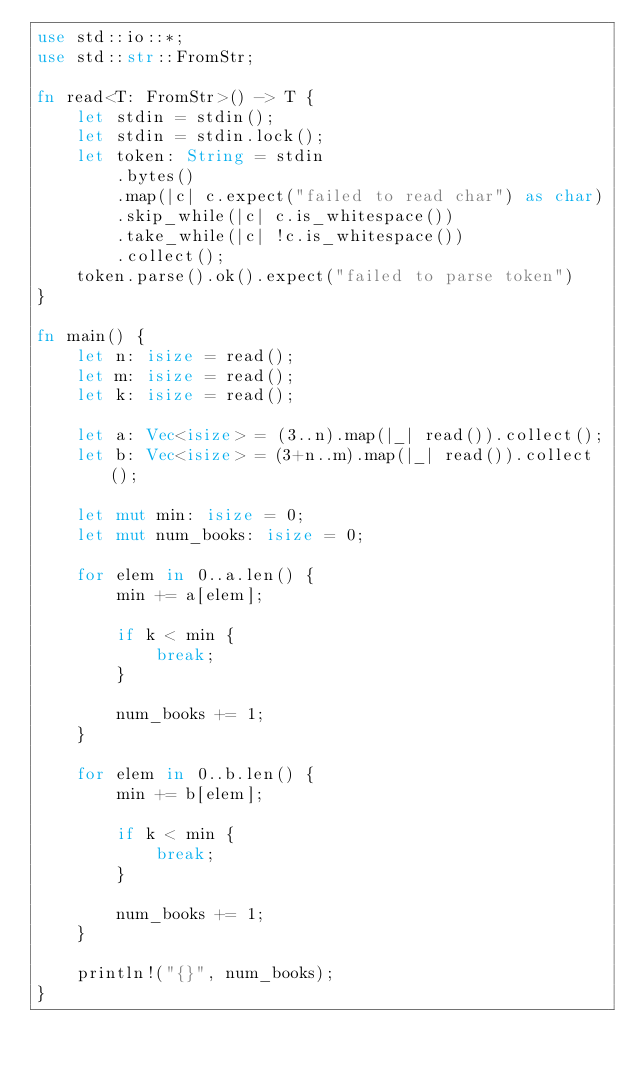Convert code to text. <code><loc_0><loc_0><loc_500><loc_500><_Rust_>use std::io::*;
use std::str::FromStr;

fn read<T: FromStr>() -> T {
    let stdin = stdin();
    let stdin = stdin.lock();
    let token: String = stdin
        .bytes()
        .map(|c| c.expect("failed to read char") as char) 
        .skip_while(|c| c.is_whitespace())
        .take_while(|c| !c.is_whitespace())
        .collect();
    token.parse().ok().expect("failed to parse token")
}

fn main() {
    let n: isize = read();
    let m: isize = read();
    let k: isize = read();

    let a: Vec<isize> = (3..n).map(|_| read()).collect();
    let b: Vec<isize> = (3+n..m).map(|_| read()).collect();

    let mut min: isize = 0;
    let mut num_books: isize = 0;

    for elem in 0..a.len() {
        min += a[elem];

        if k < min {
            break;
        }

        num_books += 1;
    }

    for elem in 0..b.len() {
        min += b[elem];

        if k < min {
            break;
        }

        num_books += 1;
    }

    println!("{}", num_books);
}</code> 